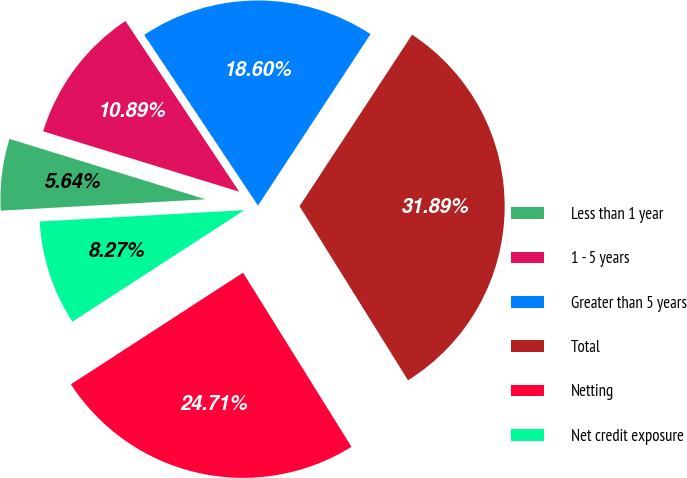Convert chart. <chart><loc_0><loc_0><loc_500><loc_500><pie_chart><fcel>Less than 1 year<fcel>1 - 5 years<fcel>Greater than 5 years<fcel>Total<fcel>Netting<fcel>Net credit exposure<nl><fcel>5.64%<fcel>10.89%<fcel>18.6%<fcel>31.89%<fcel>24.71%<fcel>8.27%<nl></chart> 